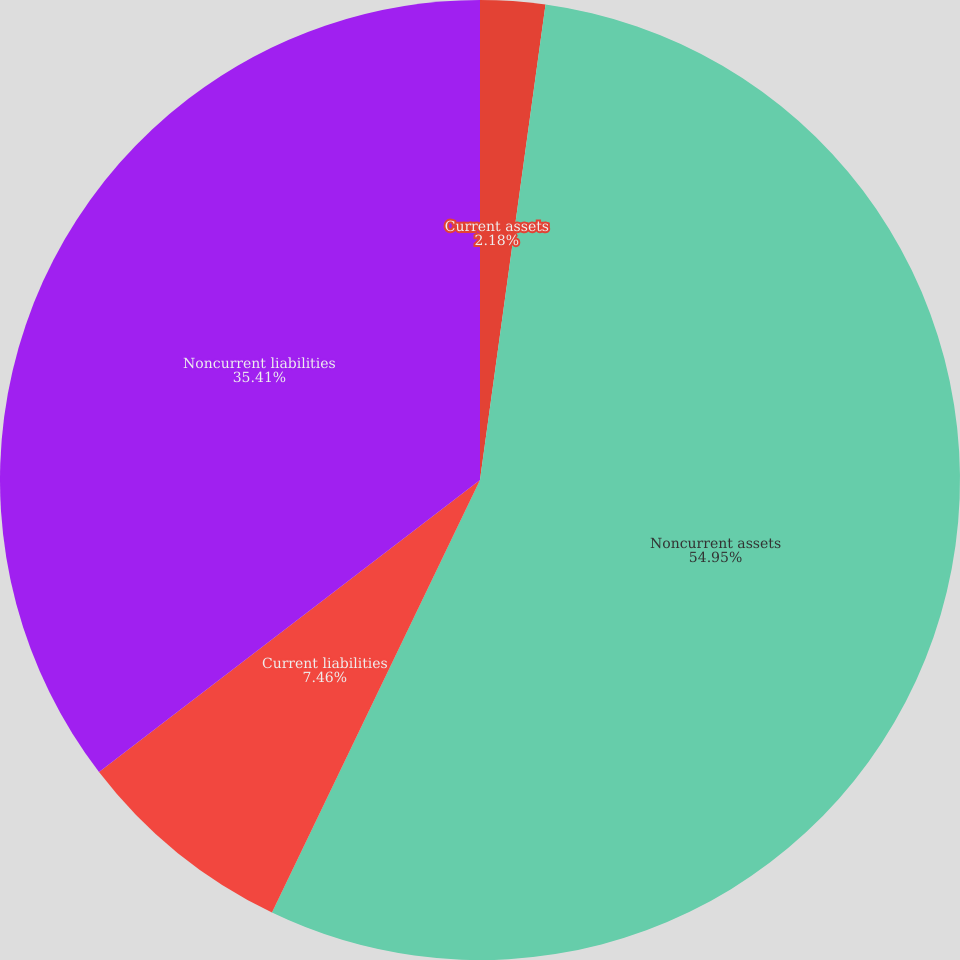Convert chart. <chart><loc_0><loc_0><loc_500><loc_500><pie_chart><fcel>Current assets<fcel>Noncurrent assets<fcel>Current liabilities<fcel>Noncurrent liabilities<nl><fcel>2.18%<fcel>54.96%<fcel>7.46%<fcel>35.41%<nl></chart> 